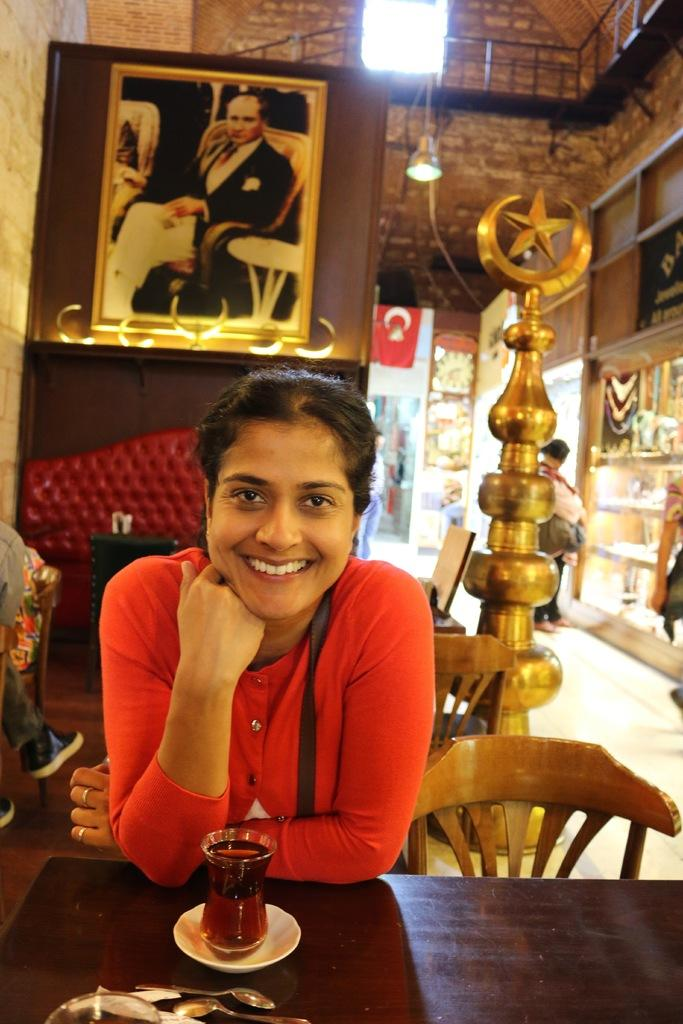Who is the main subject in the image? There is a woman in the image. What is the woman doing in the image? The woman is sitting in front of a table. What can be seen on the table in the image? There is a glass filled with juice on the table. What items are in front of the woman on the table? There are multiple spoons in front of the woman. What type of trains can be seen in the image? There are no trains present in the image. How does the woman blow on the juice in the glass? The image does not show the woman blowing on the juice; she is simply sitting in front of the table with a glass filled with juice. 